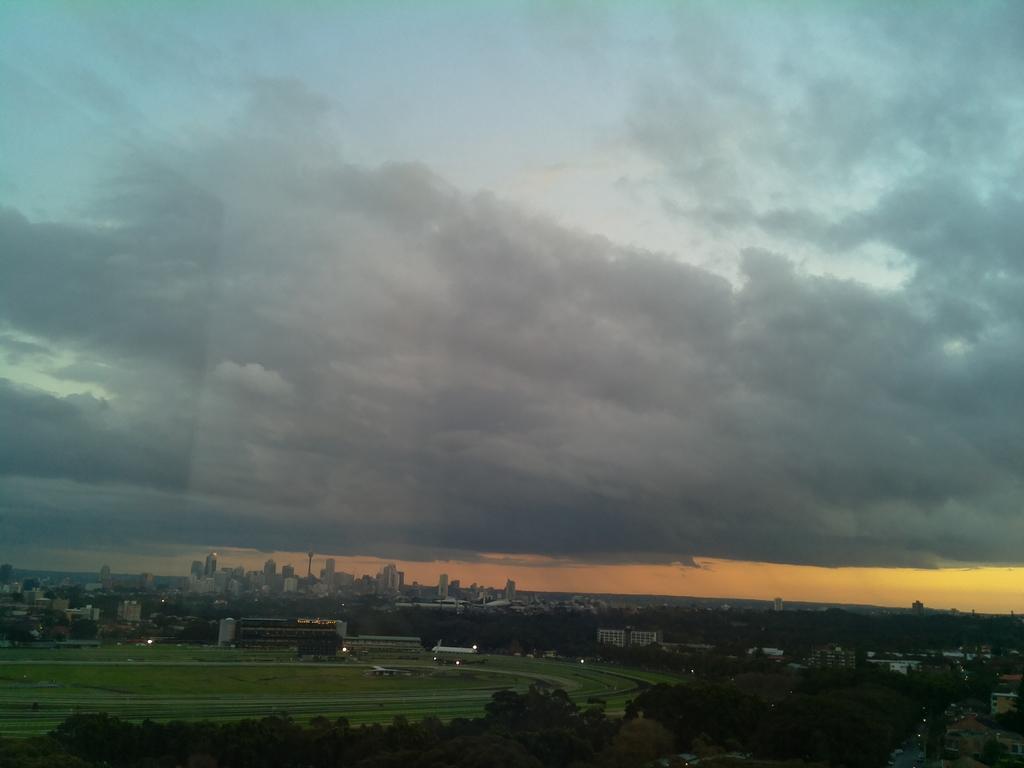In one or two sentences, can you explain what this image depicts? As we can see in the image there are buildings, grass, trees, sky and clouds. The image is little dark. 